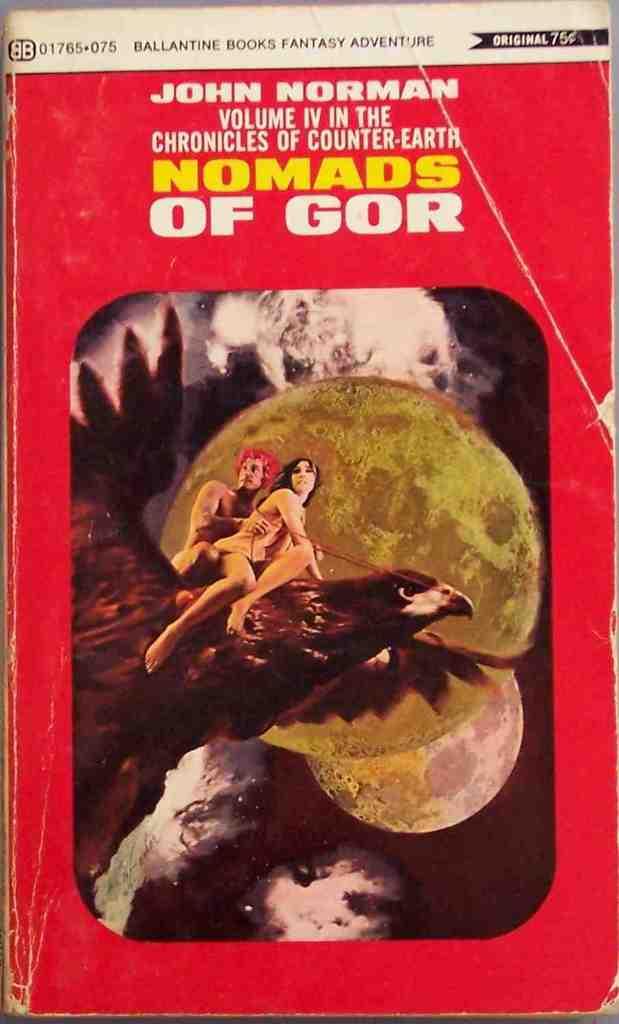What is the first name of the author who wrote this book?
Offer a very short reply. John. What is the title of john norman's work?
Your answer should be compact. Nomads of gor. 